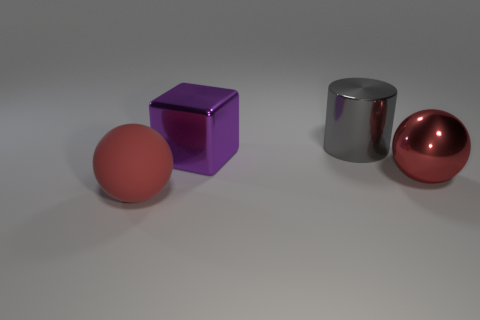Are there fewer shiny cubes that are on the left side of the rubber sphere than big blue spheres?
Your answer should be very brief. No. Is the material of the big gray thing the same as the big cube?
Make the answer very short. Yes. How many objects are large blue things or large red shiny things?
Ensure brevity in your answer.  1. What number of small green cylinders have the same material as the purple cube?
Your answer should be compact. 0. What is the size of the other red object that is the same shape as the big rubber thing?
Provide a succinct answer. Large. There is a red metal object; are there any purple metal things on the right side of it?
Your answer should be compact. No. What is the large gray thing made of?
Give a very brief answer. Metal. Does the large ball that is in front of the metallic sphere have the same color as the block?
Keep it short and to the point. No. Is there any other thing that has the same shape as the gray thing?
Offer a very short reply. No. There is another object that is the same shape as the large matte object; what is its color?
Your answer should be very brief. Red. 